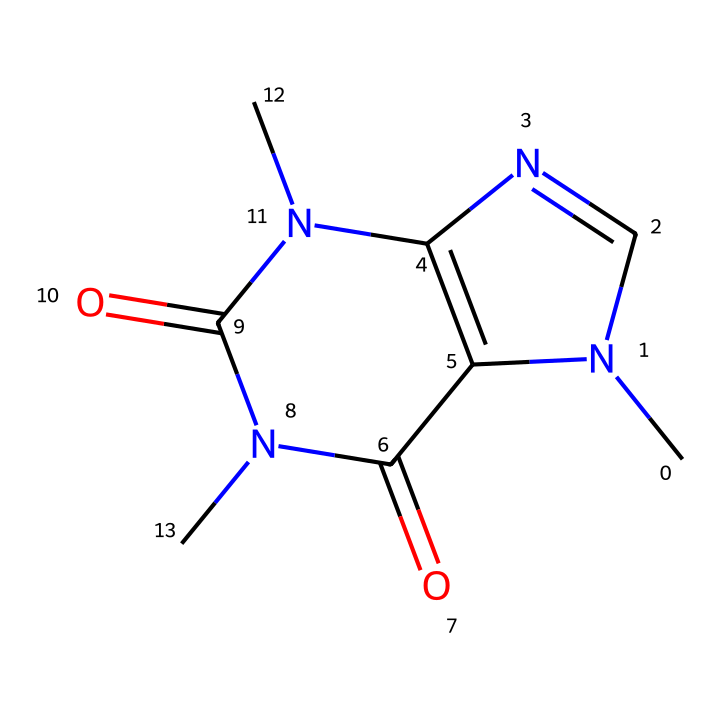What is the molecular formula of caffeine? To determine the molecular formula, we need to count the number of each type of atom present in the structure. From the SMILES, we observe the presence of carbon (C), nitrogen (N), and oxygen (O) atoms. By counting, we find there are 8 carbon atoms, 10 hydrogen atoms, 4 nitrogen atoms, and 2 oxygen atoms, giving us the formula C8H10N4O2.
Answer: C8H10N4O2 How many nitrogen atoms are in the structure? From the SMILES representation, we can identify multiple nitrogen (N) atoms. By carefully analyzing the structure, we can see there are a total of 4 nitrogen atoms present.
Answer: 4 What type of compound is caffeine classified as? Caffeine is classified as an alkaloid, which is a category of organic compounds that mostly contain basic nitrogen atoms. In this structure, the presence of nitrogen atoms and its biological effects signify its classification as an alkaloid.
Answer: alkaloid What does the presence of nitrogen atoms indicate about caffeine's properties? The presence of nitrogen atoms typically suggests that the compound may have basic characteristics and biological activity, as many nitrogen-containing compounds are active in biological systems. In the case of caffeine, its nitrogen content is crucial for its stimulant properties.
Answer: biological activity How many rings are present in the caffeine structure? By examining the structure represented by the SMILES, we can observe that there are two interconnected rings present in the caffeine molecule, which are key to its overall structure and stability.
Answer: 2 Is caffeine a saturated or unsaturated compound? Caffeine is considered unsaturated because it contains multiple double bonds in its structure, which we can identify by analyzing the connectivity of the carbon atoms and the presence of double bonds with the nitrogen and oxygen atoms.
Answer: unsaturated 